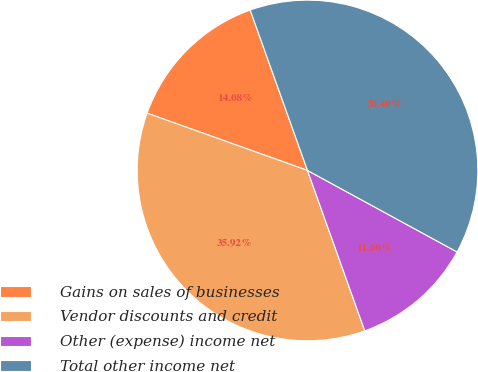<chart> <loc_0><loc_0><loc_500><loc_500><pie_chart><fcel>Gains on sales of businesses<fcel>Vendor discounts and credit<fcel>Other (expense) income net<fcel>Total other income net<nl><fcel>14.08%<fcel>35.92%<fcel>11.6%<fcel>38.4%<nl></chart> 